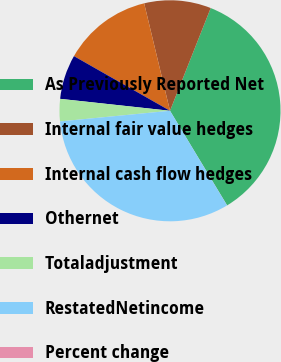Convert chart. <chart><loc_0><loc_0><loc_500><loc_500><pie_chart><fcel>As Previously Reported Net<fcel>Internal fair value hedges<fcel>Internal cash flow hedges<fcel>Othernet<fcel>Totaladjustment<fcel>RestatedNetincome<fcel>Percent change<nl><fcel>35.35%<fcel>9.76%<fcel>13.01%<fcel>6.51%<fcel>3.26%<fcel>32.1%<fcel>0.01%<nl></chart> 